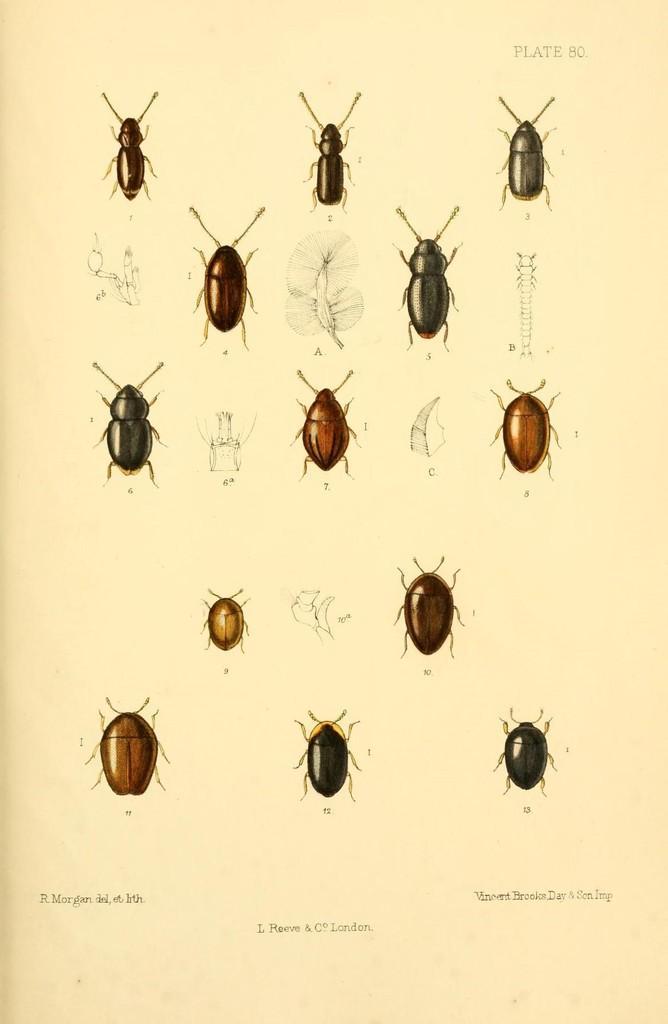Please provide a concise description of this image. In this picture I can see the depiction of insects and I see something is written on the top right and bottom of this picture. 